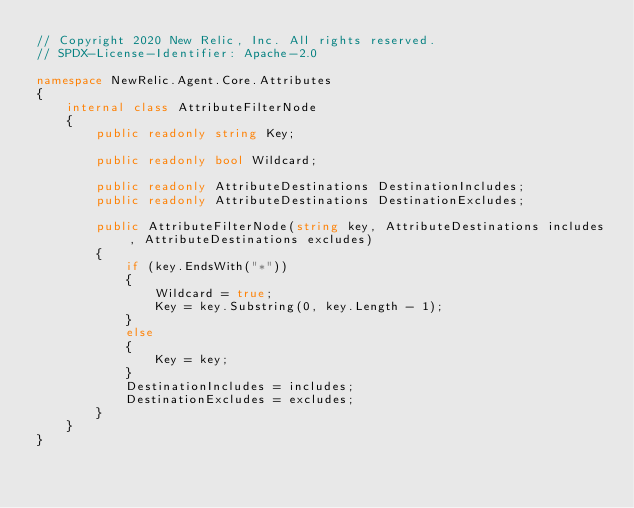Convert code to text. <code><loc_0><loc_0><loc_500><loc_500><_C#_>// Copyright 2020 New Relic, Inc. All rights reserved.
// SPDX-License-Identifier: Apache-2.0

namespace NewRelic.Agent.Core.Attributes
{
    internal class AttributeFilterNode
    {
        public readonly string Key;

        public readonly bool Wildcard;

        public readonly AttributeDestinations DestinationIncludes;
        public readonly AttributeDestinations DestinationExcludes;

        public AttributeFilterNode(string key, AttributeDestinations includes, AttributeDestinations excludes)
        {
            if (key.EndsWith("*"))
            {
                Wildcard = true;
                Key = key.Substring(0, key.Length - 1);
            }
            else
            {
                Key = key;
            }
            DestinationIncludes = includes;
            DestinationExcludes = excludes;
        }
    }
}
</code> 